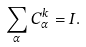Convert formula to latex. <formula><loc_0><loc_0><loc_500><loc_500>\sum _ { \alpha } C _ { \alpha } ^ { k } = I .</formula> 